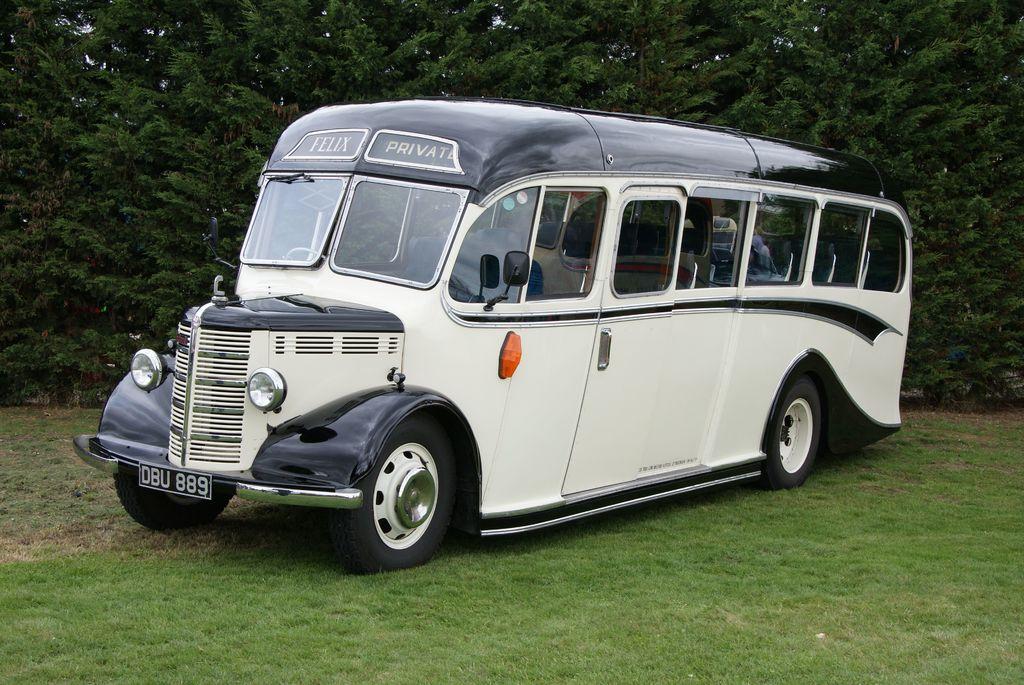What is the license plate number?
Your answer should be very brief. Dbu 889. 